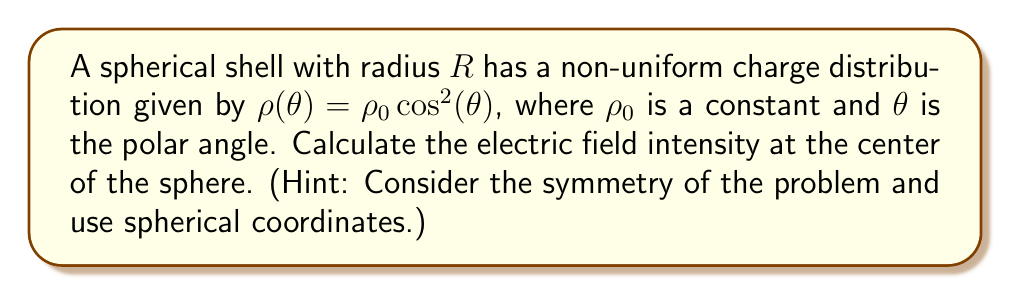Help me with this question. Let's approach this step-by-step:

1) The electric field intensity $\vec{E}$ at a point due to a continuous charge distribution is given by:

   $$\vec{E} = \frac{1}{4\pi\epsilon_0} \int \frac{\rho(\vec{r'})}{\left|\vec{r}-\vec{r'}\right|^2} \hat{r} dV'$$

2) In spherical coordinates, the volume element is:

   $$dV' = r'^2 \sin\theta' d\theta' d\phi' dr'$$

3) Given the symmetry of the problem, we can simplify our calculation by noting that the electric field at the center will be zero due to the symmetrical cancellation of opposite charges.

4) However, let's prove this mathematically. At the center, $\vec{r} = 0$, so $\left|\vec{r}-\vec{r'}\right| = r'$. The unit vector $\hat{r}$ points from the charge element to the center, so $\hat{r} = -\hat{r'}$.

5) Our integral becomes:

   $$\vec{E} = -\frac{1}{4\pi\epsilon_0} \int_0^{2\pi} \int_0^{\pi} \int_0^R \frac{\rho_0 \cos^2\theta'}{r'^2} \hat{r'} r'^2 \sin\theta' d\theta' d\phi' dr'$$

6) Simplifying:

   $$\vec{E} = -\frac{\rho_0}{4\pi\epsilon_0} \int_0^{2\pi} \int_0^{\pi} \int_0^R \cos^2\theta' \sin\theta' \hat{r'} d\theta' d\phi' dr'$$

7) The $\hat{r'}$ component can be written as $\sin\theta' \cos\phi' \hat{i} + \sin\theta' \sin\phi' \hat{j} + \cos\theta' \hat{k}$

8) After integration over $\phi'$ from 0 to $2\pi$, the $\hat{i}$ and $\hat{j}$ components vanish due to symmetry. We're left with:

   $$\vec{E} = -\frac{\rho_0 R}{2\epsilon_0} \int_0^{\pi} \cos^2\theta' \sin\theta' \cos\theta' d\theta' \hat{k}$$

9) This integral evaluates to zero because $\int_0^{\pi} \cos^3\theta' \sin\theta' d\theta' = 0$.

Therefore, the electric field at the center of the sphere is zero.
Answer: $\vec{E} = 0$ 